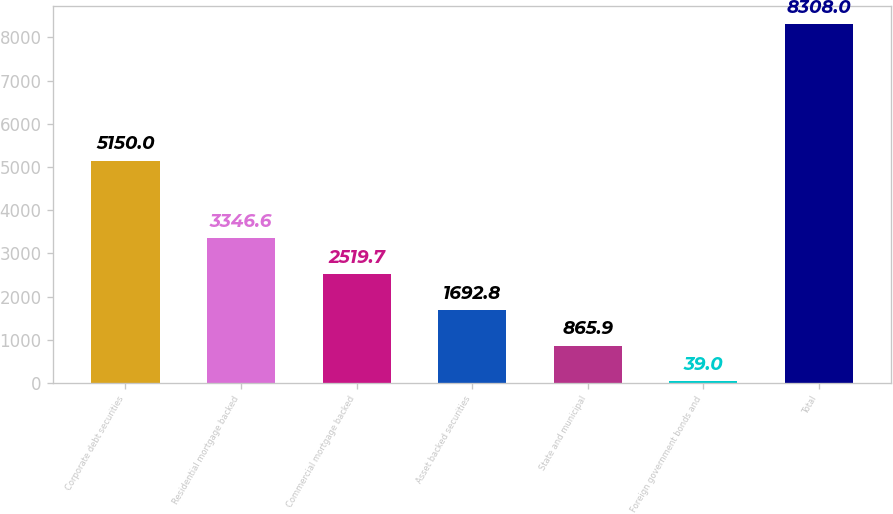Convert chart to OTSL. <chart><loc_0><loc_0><loc_500><loc_500><bar_chart><fcel>Corporate debt securities<fcel>Residential mortgage backed<fcel>Commercial mortgage backed<fcel>Asset backed securities<fcel>State and municipal<fcel>Foreign government bonds and<fcel>Total<nl><fcel>5150<fcel>3346.6<fcel>2519.7<fcel>1692.8<fcel>865.9<fcel>39<fcel>8308<nl></chart> 